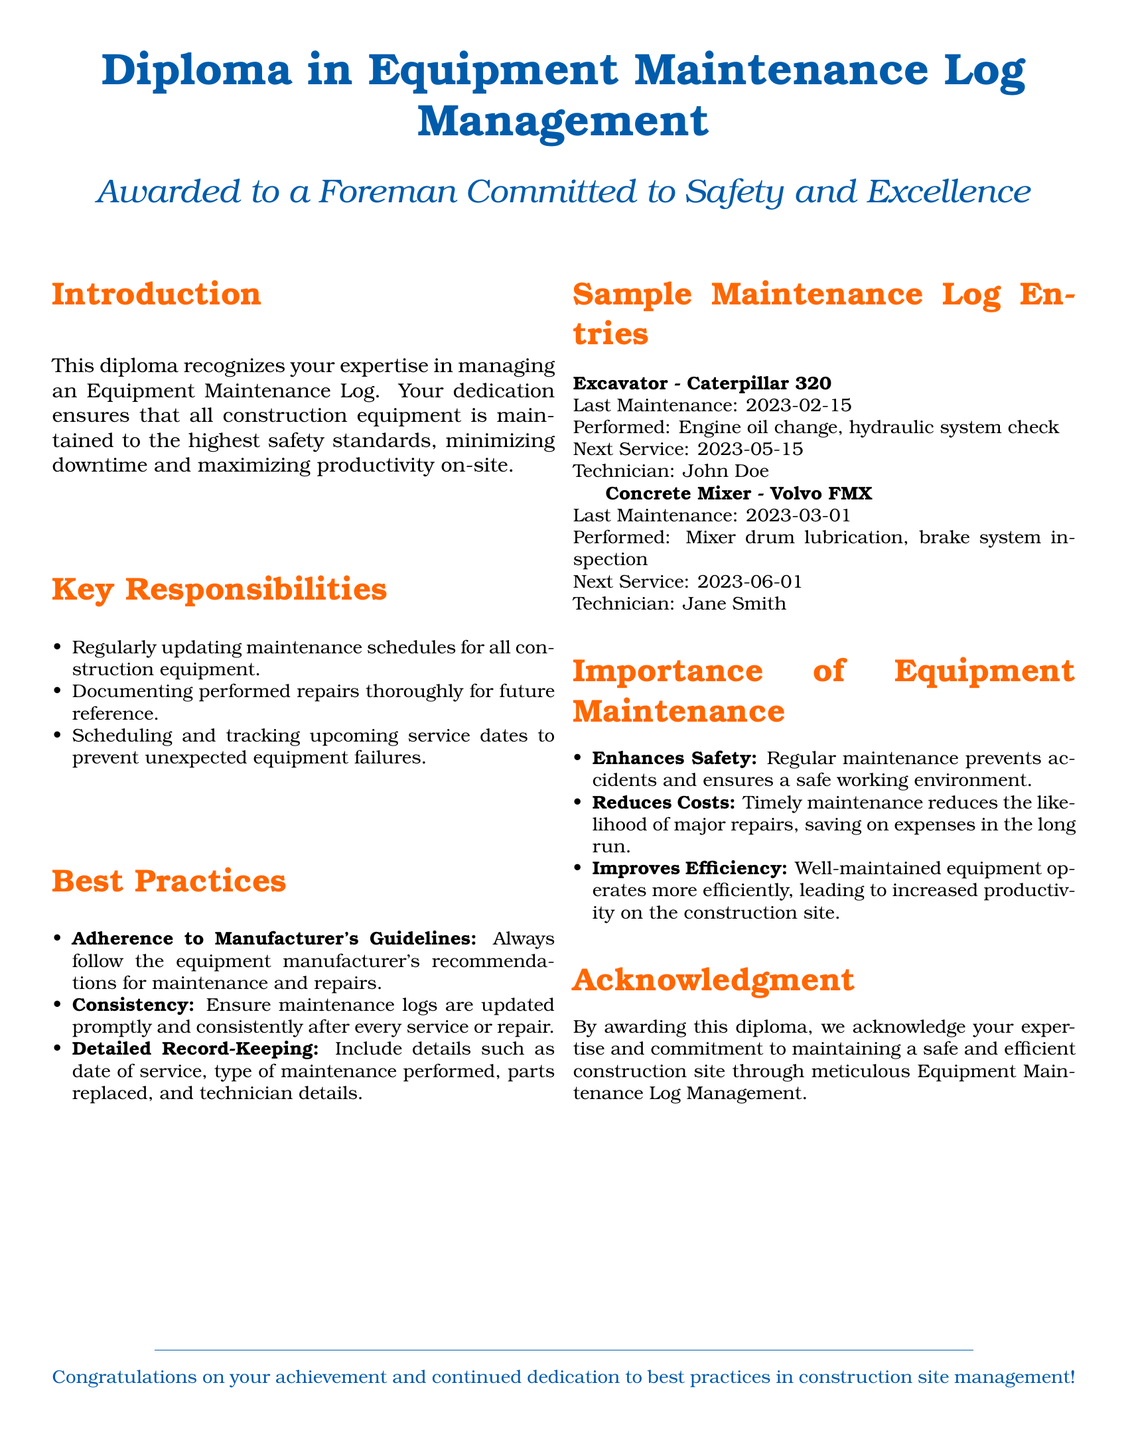What is the title of the diploma? The title of the diploma is prominently displayed at the top of the document and indicates what it recognizes.
Answer: Diploma in Equipment Maintenance Log Management Who is the diploma awarded to? The document states that the diploma is awarded to an individual displaying specific qualities and commitment.
Answer: A Foreman Committed to Safety and Excellence What date was the last maintenance performed on the Excavator? The document lists the last maintenance date for the Excavator as part of its sample entries.
Answer: 2023-02-15 What type of maintenance was performed on the Concrete Mixer? This information can be found in the log entry for the Concrete Mixer, detailing the maintenance tasks executed.
Answer: Mixer drum lubrication, brake system inspection What is the next service date for the Excavator? This date is specified in the maintenance log entry for the Excavator section of the document.
Answer: 2023-05-15 What is one key responsibility of the foreman regarding equipment maintenance? The document contains a list of responsibilities, outlining the tasks the foreman must prioritize.
Answer: Regularly updating maintenance schedules What enhances safety on the construction site according to the document? The document emphasizes the importance of specific practices related to equipment maintenance.
Answer: Regular maintenance Which technician performed the maintenance on the Excavator? The maintenance log includes the name of the technician who worked on the Excavator.
Answer: John Doe What is the color used for section headings in the document? The color scheme for headings is explicitly defined in the document's styling section.
Answer: Safety orange 